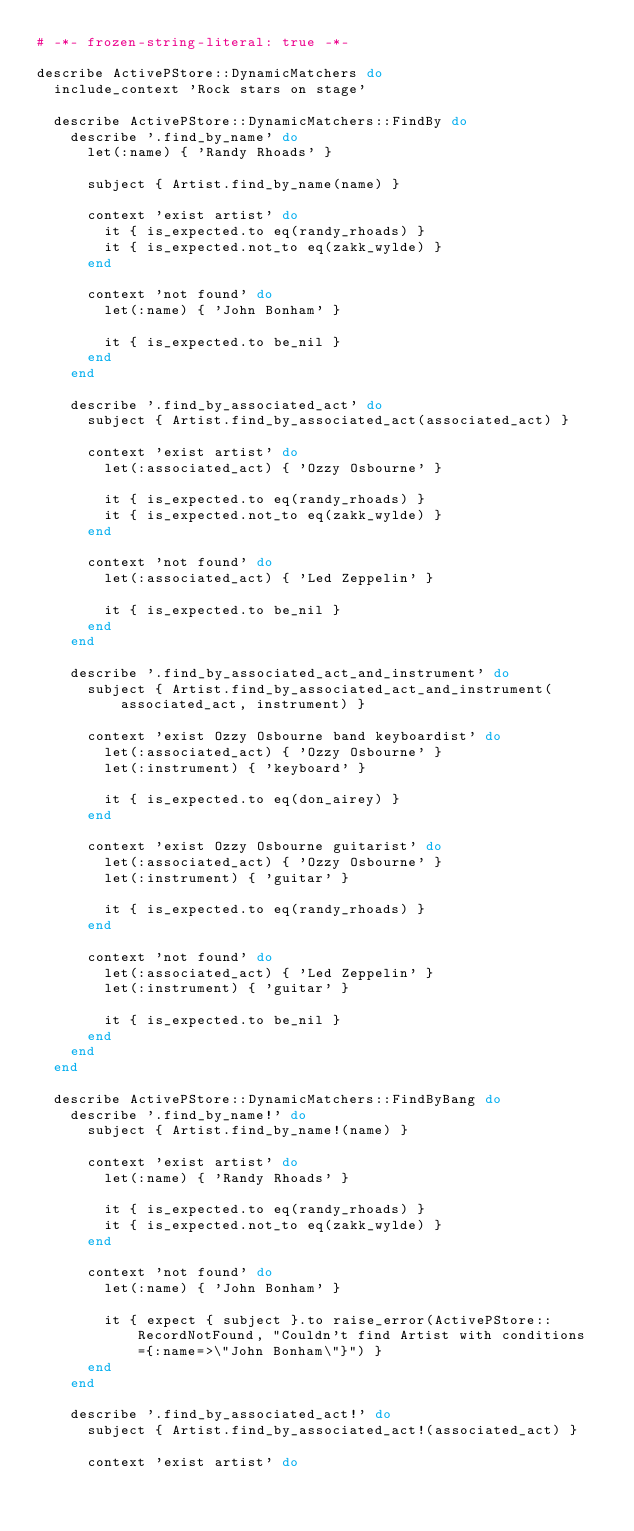<code> <loc_0><loc_0><loc_500><loc_500><_Ruby_># -*- frozen-string-literal: true -*-

describe ActivePStore::DynamicMatchers do
  include_context 'Rock stars on stage'

  describe ActivePStore::DynamicMatchers::FindBy do
    describe '.find_by_name' do
      let(:name) { 'Randy Rhoads' }

      subject { Artist.find_by_name(name) }

      context 'exist artist' do
        it { is_expected.to eq(randy_rhoads) }
        it { is_expected.not_to eq(zakk_wylde) }
      end

      context 'not found' do
        let(:name) { 'John Bonham' }

        it { is_expected.to be_nil }
      end
    end

    describe '.find_by_associated_act' do
      subject { Artist.find_by_associated_act(associated_act) }

      context 'exist artist' do
        let(:associated_act) { 'Ozzy Osbourne' }

        it { is_expected.to eq(randy_rhoads) }
        it { is_expected.not_to eq(zakk_wylde) }
      end

      context 'not found' do
        let(:associated_act) { 'Led Zeppelin' }

        it { is_expected.to be_nil }
      end
    end

    describe '.find_by_associated_act_and_instrument' do
      subject { Artist.find_by_associated_act_and_instrument(associated_act, instrument) }

      context 'exist Ozzy Osbourne band keyboardist' do
        let(:associated_act) { 'Ozzy Osbourne' }
        let(:instrument) { 'keyboard' }

        it { is_expected.to eq(don_airey) }
      end

      context 'exist Ozzy Osbourne guitarist' do
        let(:associated_act) { 'Ozzy Osbourne' }
        let(:instrument) { 'guitar' }

        it { is_expected.to eq(randy_rhoads) }
      end

      context 'not found' do
        let(:associated_act) { 'Led Zeppelin' }
        let(:instrument) { 'guitar' }

        it { is_expected.to be_nil }
      end
    end
  end

  describe ActivePStore::DynamicMatchers::FindByBang do
    describe '.find_by_name!' do
      subject { Artist.find_by_name!(name) }

      context 'exist artist' do
        let(:name) { 'Randy Rhoads' }

        it { is_expected.to eq(randy_rhoads) }
        it { is_expected.not_to eq(zakk_wylde) }
      end

      context 'not found' do
        let(:name) { 'John Bonham' }

        it { expect { subject }.to raise_error(ActivePStore::RecordNotFound, "Couldn't find Artist with conditions={:name=>\"John Bonham\"}") }
      end
    end

    describe '.find_by_associated_act!' do
      subject { Artist.find_by_associated_act!(associated_act) }

      context 'exist artist' do</code> 